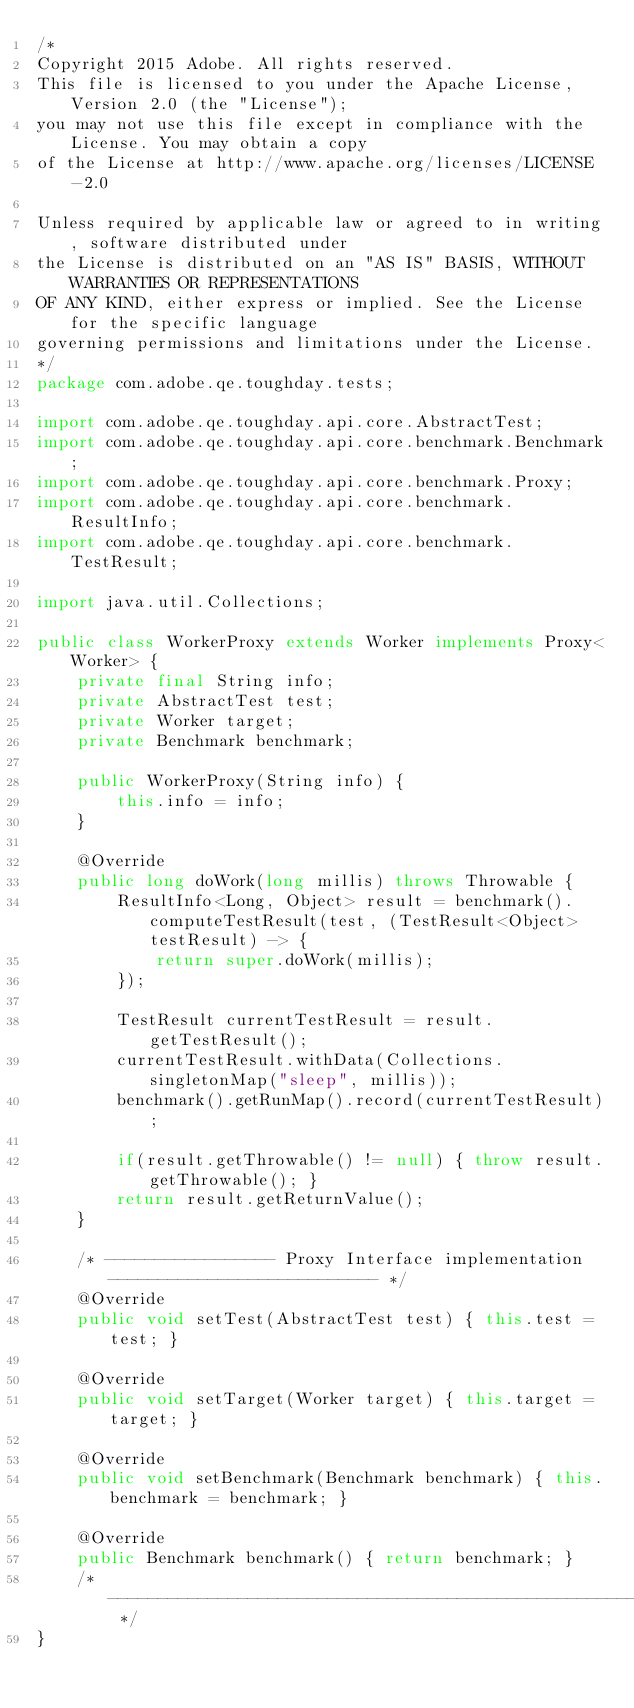Convert code to text. <code><loc_0><loc_0><loc_500><loc_500><_Java_>/*
Copyright 2015 Adobe. All rights reserved.
This file is licensed to you under the Apache License, Version 2.0 (the "License");
you may not use this file except in compliance with the License. You may obtain a copy
of the License at http://www.apache.org/licenses/LICENSE-2.0

Unless required by applicable law or agreed to in writing, software distributed under
the License is distributed on an "AS IS" BASIS, WITHOUT WARRANTIES OR REPRESENTATIONS
OF ANY KIND, either express or implied. See the License for the specific language
governing permissions and limitations under the License.
*/
package com.adobe.qe.toughday.tests;

import com.adobe.qe.toughday.api.core.AbstractTest;
import com.adobe.qe.toughday.api.core.benchmark.Benchmark;
import com.adobe.qe.toughday.api.core.benchmark.Proxy;
import com.adobe.qe.toughday.api.core.benchmark.ResultInfo;
import com.adobe.qe.toughday.api.core.benchmark.TestResult;

import java.util.Collections;

public class WorkerProxy extends Worker implements Proxy<Worker> {
    private final String info;
    private AbstractTest test;
    private Worker target;
    private Benchmark benchmark;
    
    public WorkerProxy(String info) {
        this.info = info;
    }

    @Override
    public long doWork(long millis) throws Throwable {
        ResultInfo<Long, Object> result = benchmark().computeTestResult(test, (TestResult<Object> testResult) -> {
            return super.doWork(millis);
        });

        TestResult currentTestResult = result.getTestResult();
        currentTestResult.withData(Collections.singletonMap("sleep", millis));
        benchmark().getRunMap().record(currentTestResult);

        if(result.getThrowable() != null) { throw result.getThrowable(); }
        return result.getReturnValue();
    }

    /* ----------------- Proxy Interface implementation --------------------------- */
    @Override
    public void setTest(AbstractTest test) { this.test = test; }

    @Override
    public void setTarget(Worker target) { this.target = target; }

    @Override
    public void setBenchmark(Benchmark benchmark) { this.benchmark = benchmark; }

    @Override
    public Benchmark benchmark() { return benchmark; }
    /* --------------------------------------------------------------------------- */
}
</code> 